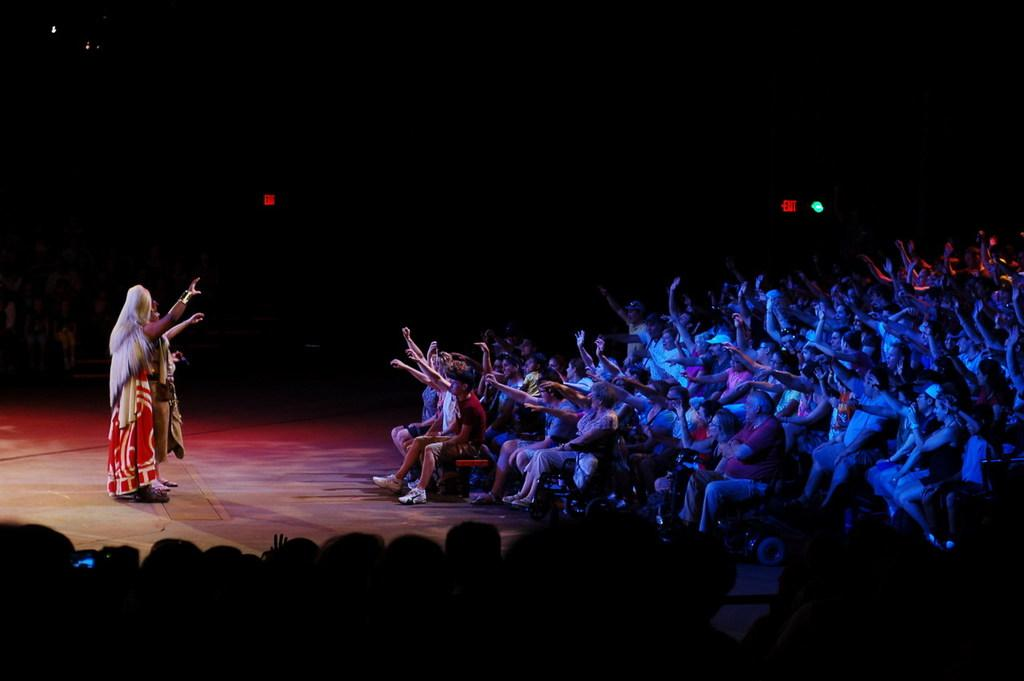What is happening in the image involving a group of people? The people in the image are sitting on cars. Are there any individuals in the image who are not sitting on cars? Yes, there are two persons standing in the image. What can be seen in the image that provides illumination? There are lights visible in the image. How would you describe the overall lighting in the image? The background of the image is dark. What is the chance of a dog appearing in the image? There is no dog present in the image, so it is not possible to determine the chance of a dog appearing. 